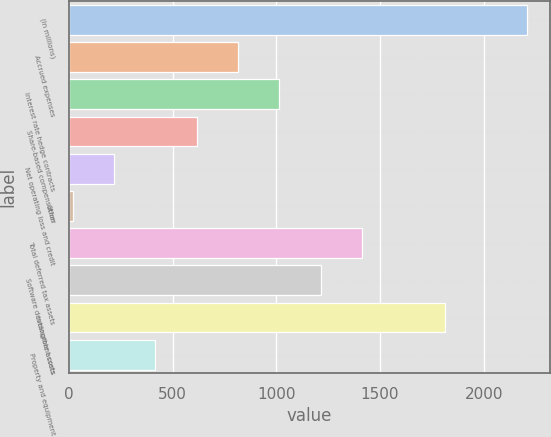<chart> <loc_0><loc_0><loc_500><loc_500><bar_chart><fcel>(In millions)<fcel>Accrued expenses<fcel>Interest rate hedge contracts<fcel>Share-based compensation<fcel>Net operating loss and credit<fcel>Other<fcel>Total deferred tax assets<fcel>Software development costs<fcel>Intangible assets<fcel>Property and equipment<nl><fcel>2209.1<fcel>815.4<fcel>1014.5<fcel>616.3<fcel>218.1<fcel>19<fcel>1412.7<fcel>1213.6<fcel>1810.9<fcel>417.2<nl></chart> 